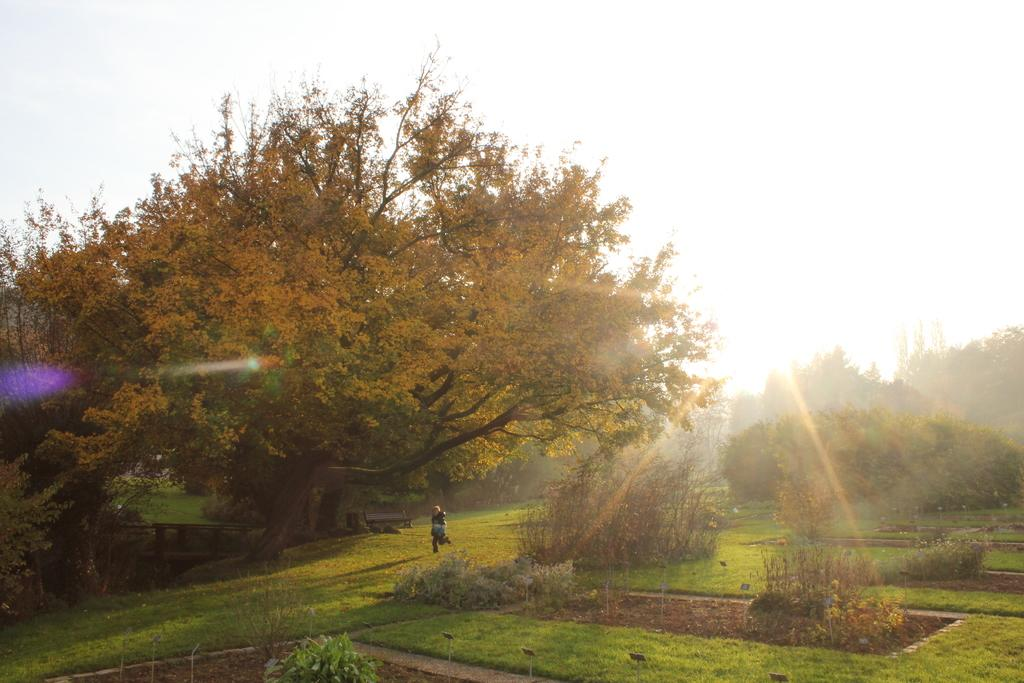What type of vegetation can be seen in the image? There are trees in the image. What is on the ground in the image? There is grass on the ground in the image. What is the person in the image doing? The person is running in the image. What can be seen in the background of the image? The sky is visible in the background of the image. Is the queen present in the image, and is she involved in a bubble fight? There is no queen or bubble fight present in the image; it features trees, grass, and a person running. 